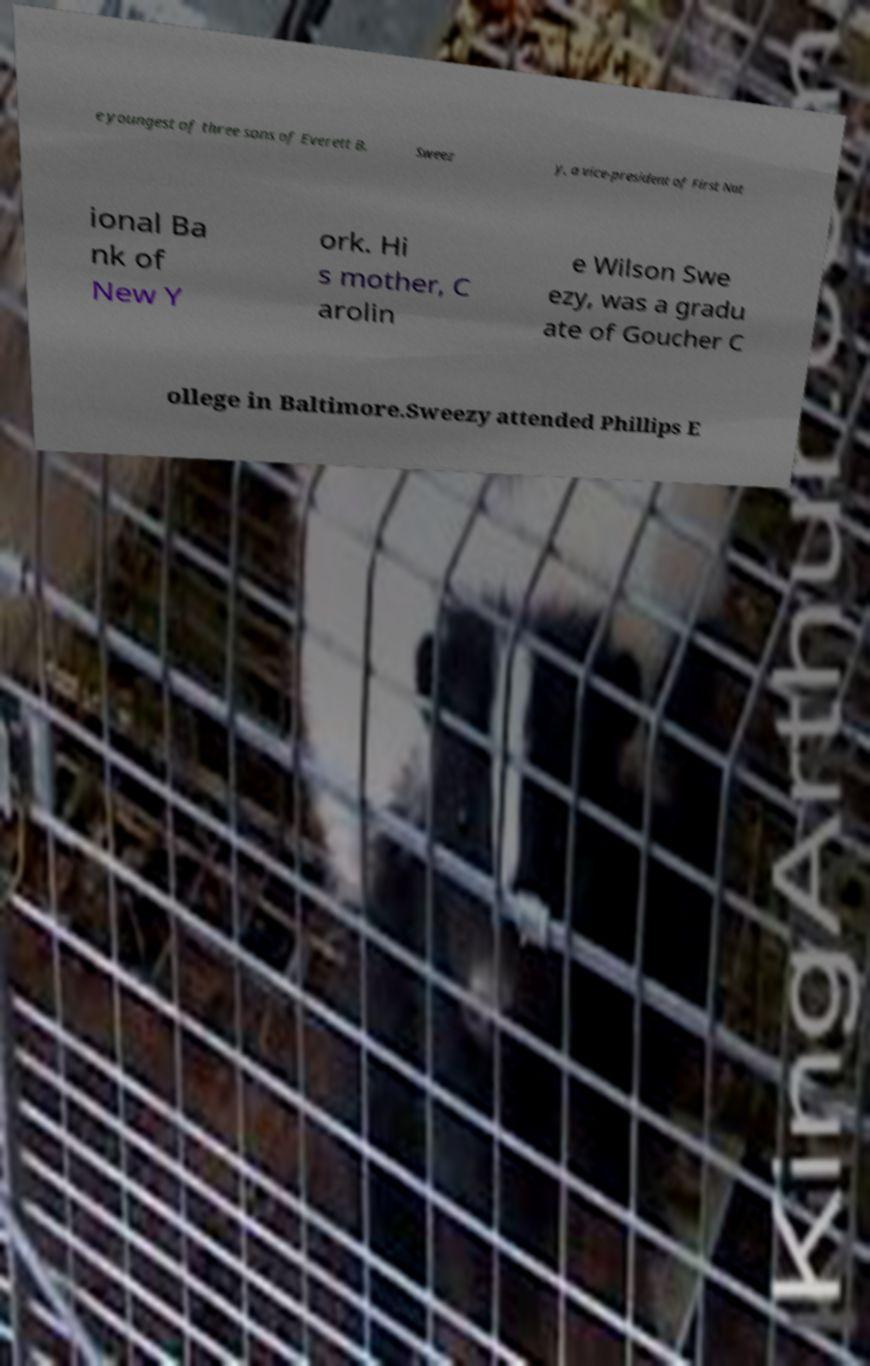Please read and relay the text visible in this image. What does it say? e youngest of three sons of Everett B. Sweez y, a vice-president of First Nat ional Ba nk of New Y ork. Hi s mother, C arolin e Wilson Swe ezy, was a gradu ate of Goucher C ollege in Baltimore.Sweezy attended Phillips E 